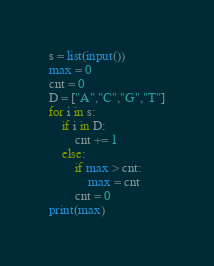Convert code to text. <code><loc_0><loc_0><loc_500><loc_500><_Python_>s = list(input())
max = 0
cnt = 0
D = ["A","C","G","T"]
for i in s:
    if i in D:
        cnt += 1
    else:
        if max > cnt:
            max = cnt
        cnt = 0
print(max)</code> 